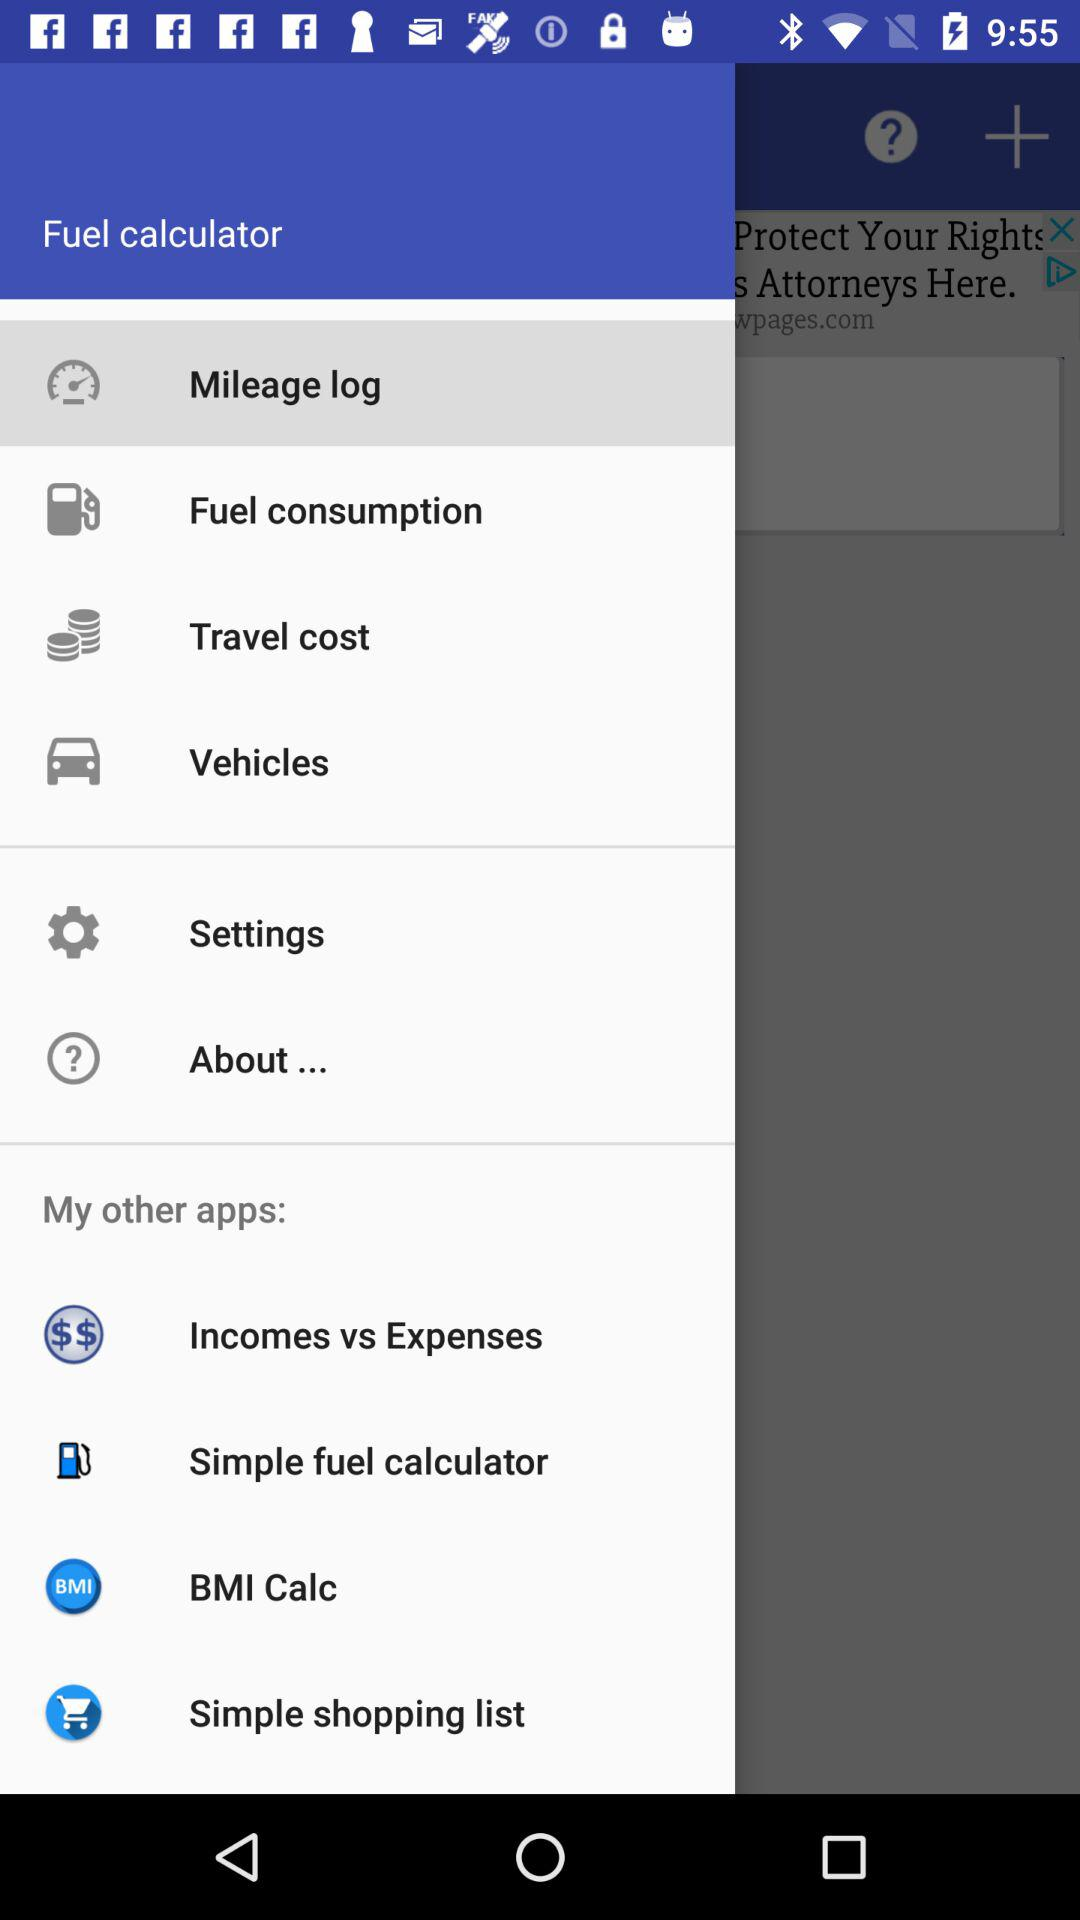How many items are in the 'My other apps' section?
Answer the question using a single word or phrase. 4 